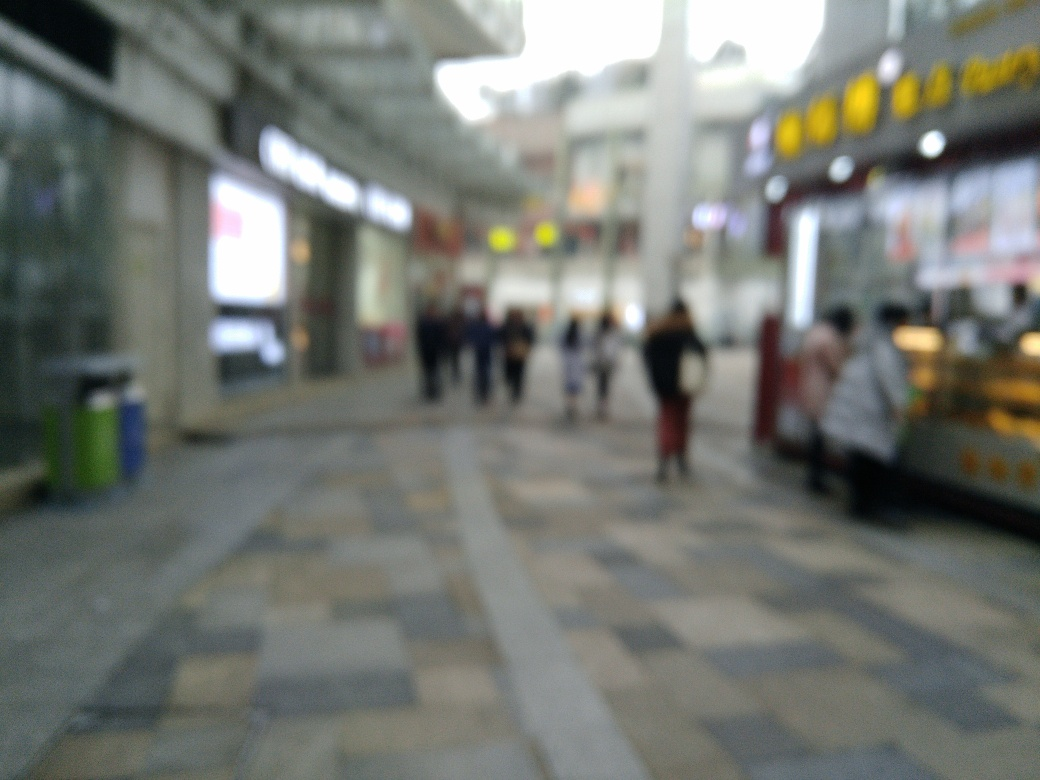Are there any quality issues with this image? Yes, the image is blurred, which affects its clarity and sharpness, making it difficult to discern fine details. This blur could be due to motion, an out-of-focus camera lens, or a low-quality camera sensor. 